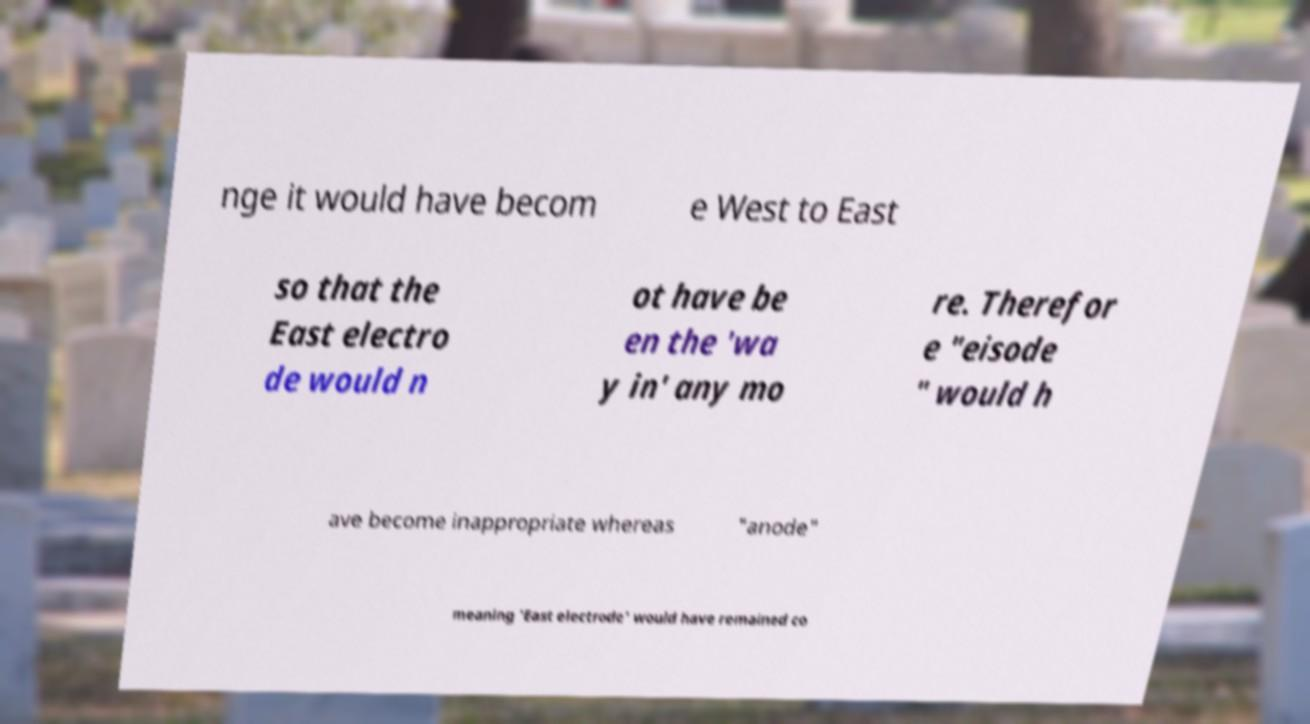Can you read and provide the text displayed in the image?This photo seems to have some interesting text. Can you extract and type it out for me? nge it would have becom e West to East so that the East electro de would n ot have be en the 'wa y in' any mo re. Therefor e "eisode " would h ave become inappropriate whereas "anode" meaning 'East electrode' would have remained co 